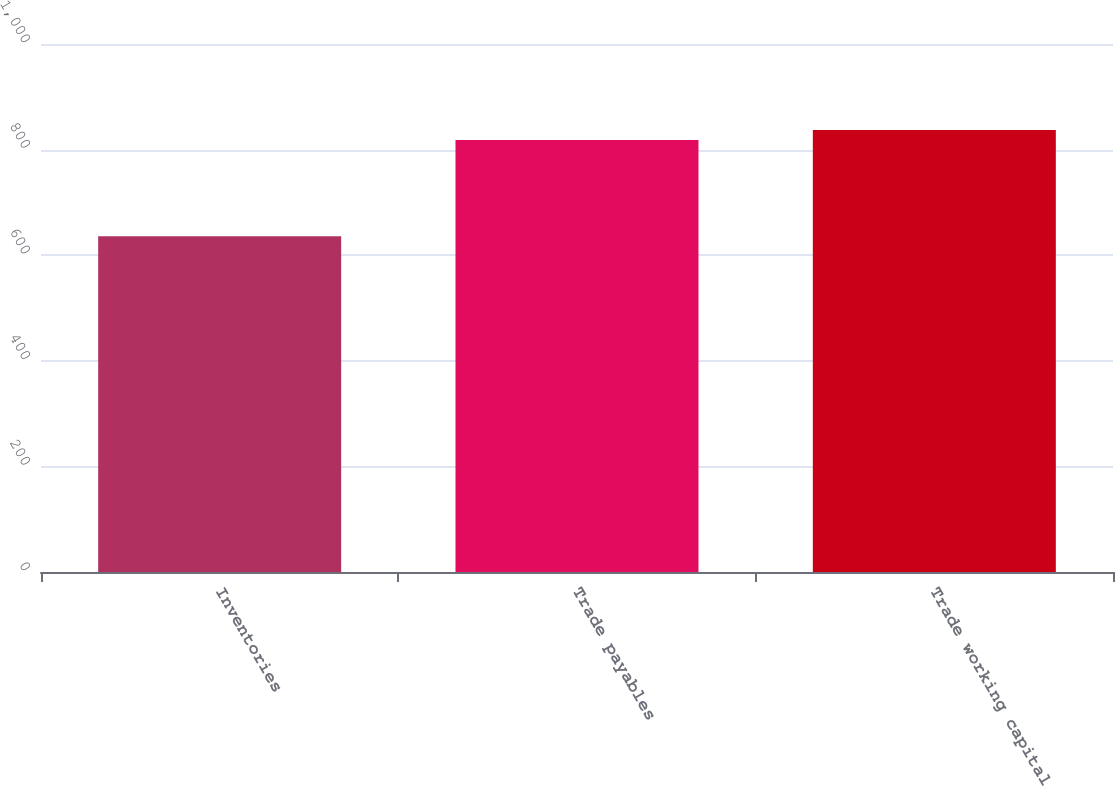<chart> <loc_0><loc_0><loc_500><loc_500><bar_chart><fcel>Inventories<fcel>Trade payables<fcel>Trade working capital<nl><fcel>636<fcel>818<fcel>837.1<nl></chart> 